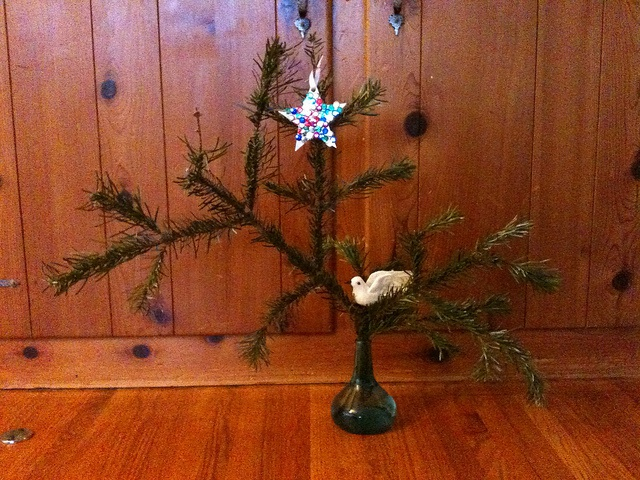Describe the objects in this image and their specific colors. I can see potted plant in salmon, maroon, black, and brown tones, vase in salmon, black, maroon, and gray tones, and bird in salmon, tan, and beige tones in this image. 